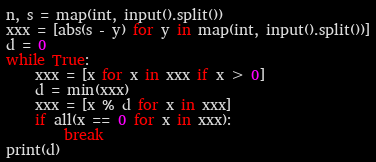Convert code to text. <code><loc_0><loc_0><loc_500><loc_500><_Python_>n, s = map(int, input().split())
xxx = [abs(s - y) for y in map(int, input().split())]
d = 0
while True:
    xxx = [x for x in xxx if x > 0]
    d = min(xxx)
    xxx = [x % d for x in xxx]
    if all(x == 0 for x in xxx):
        break
print(d)
</code> 